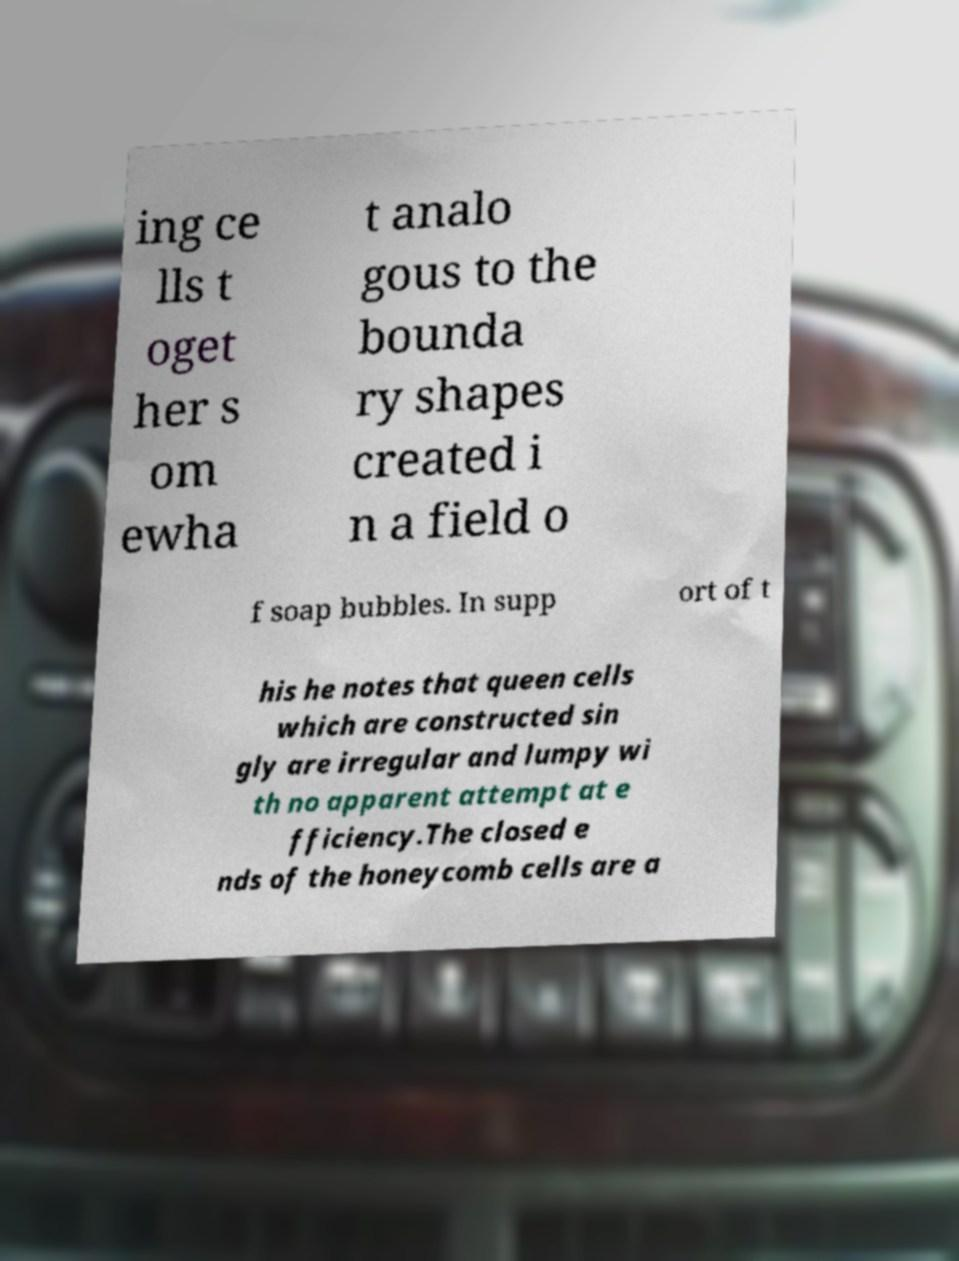What can we infer about queen cells based on the description in the image? Based on the description in the image, it seems queen cells, when constructed singly, are described as irregular and lumpy, with no clear attempt at efficiency. This may indicate that these cells, specifically built for queen bees, differ significantly in structure and design from regular honeycomb cells, perhaps due to their unique purpose and the different criteria driving their construction. 